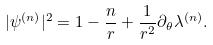<formula> <loc_0><loc_0><loc_500><loc_500>| \psi ^ { ( n ) } | ^ { 2 } = 1 - \frac { n } { r } + \frac { 1 } { r ^ { 2 } } \partial _ { \theta } \lambda ^ { ( n ) } .</formula> 